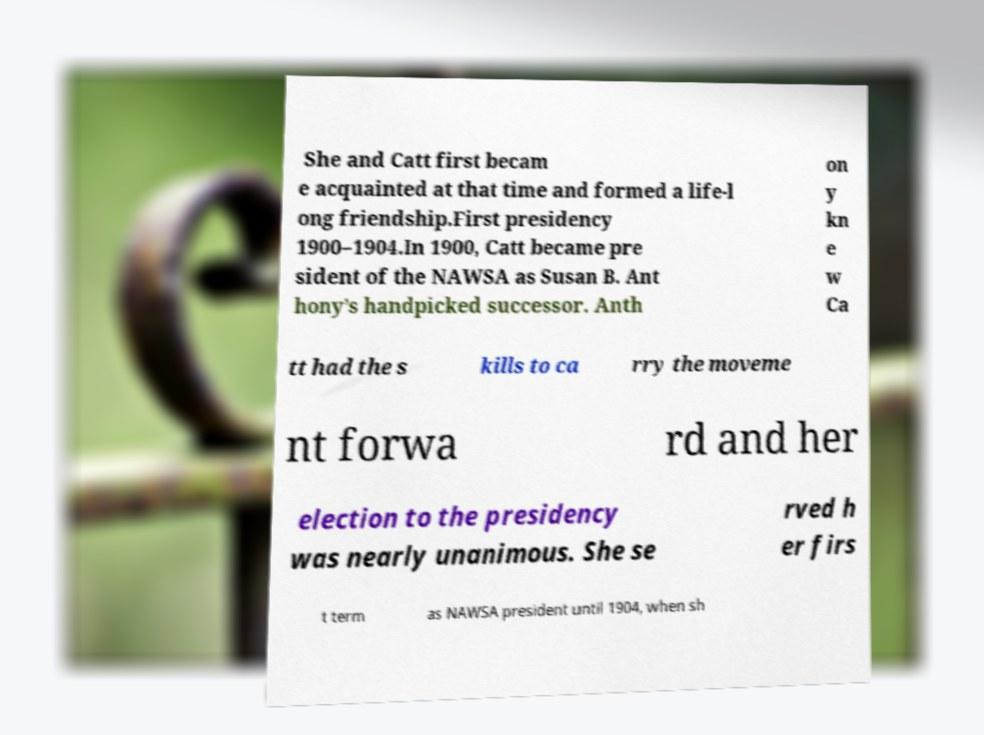For documentation purposes, I need the text within this image transcribed. Could you provide that? She and Catt first becam e acquainted at that time and formed a life-l ong friendship.First presidency 1900–1904.In 1900, Catt became pre sident of the NAWSA as Susan B. Ant hony’s handpicked successor. Anth on y kn e w Ca tt had the s kills to ca rry the moveme nt forwa rd and her election to the presidency was nearly unanimous. She se rved h er firs t term as NAWSA president until 1904, when sh 